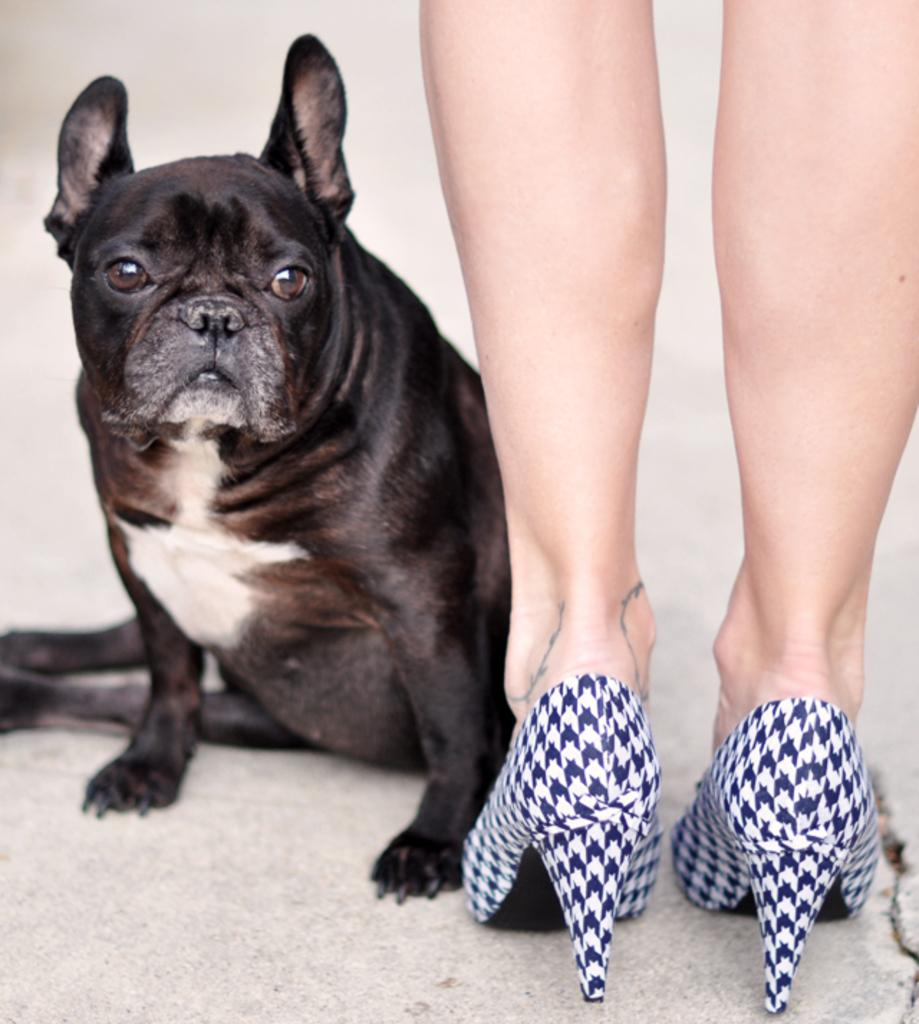What type of animal can be seen in the image? There is a dog in the image. What part of a person is visible in the image? There are person's legs visible in the image. What type of footwear is the person wearing? The person is wearing heel sandals. What is the position of the heel sandals in the image? The heel sandals are on the ground. What type of care does the dog require for its fang in the image? There is no mention of a fang in the image, and the dog's dental health is not discussed. 